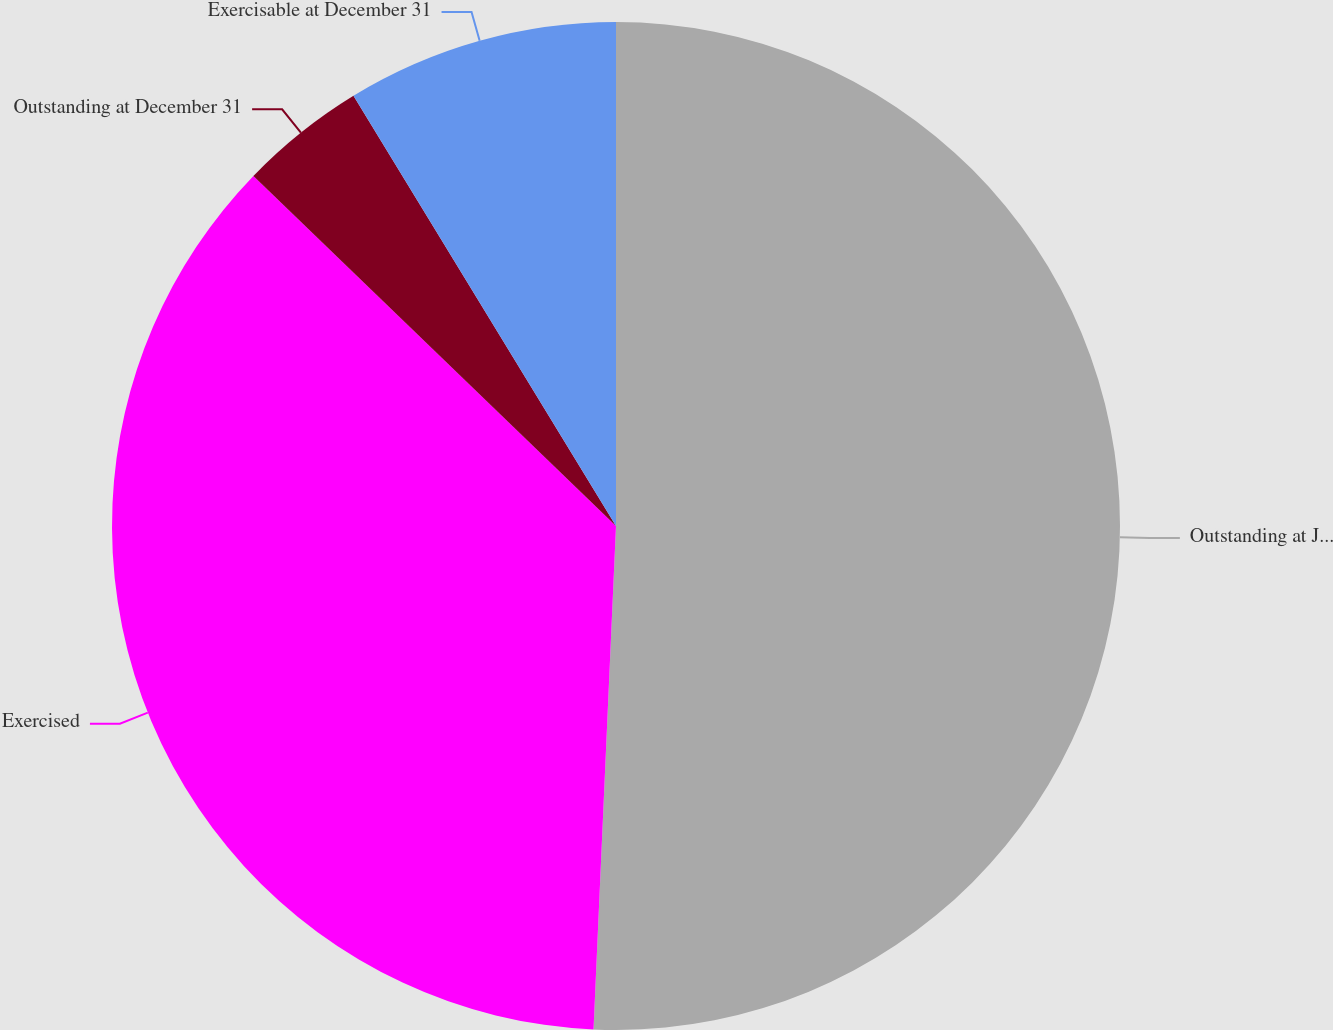Convert chart. <chart><loc_0><loc_0><loc_500><loc_500><pie_chart><fcel>Outstanding at January 1<fcel>Exercised<fcel>Outstanding at December 31<fcel>Exercisable at December 31<nl><fcel>50.71%<fcel>36.51%<fcel>4.06%<fcel>8.72%<nl></chart> 